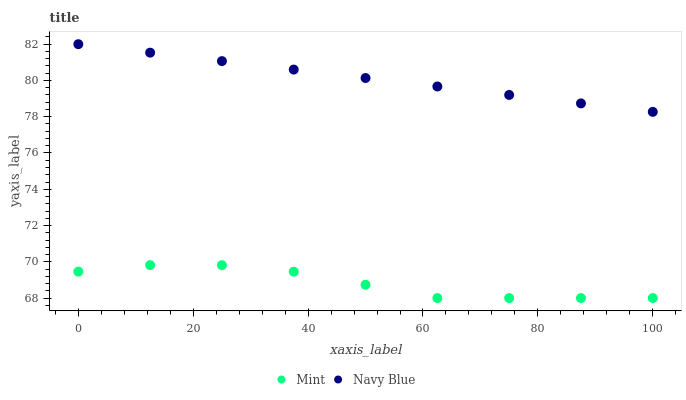Does Mint have the minimum area under the curve?
Answer yes or no. Yes. Does Navy Blue have the maximum area under the curve?
Answer yes or no. Yes. Does Mint have the maximum area under the curve?
Answer yes or no. No. Is Navy Blue the smoothest?
Answer yes or no. Yes. Is Mint the roughest?
Answer yes or no. Yes. Is Mint the smoothest?
Answer yes or no. No. Does Mint have the lowest value?
Answer yes or no. Yes. Does Navy Blue have the highest value?
Answer yes or no. Yes. Does Mint have the highest value?
Answer yes or no. No. Is Mint less than Navy Blue?
Answer yes or no. Yes. Is Navy Blue greater than Mint?
Answer yes or no. Yes. Does Mint intersect Navy Blue?
Answer yes or no. No. 